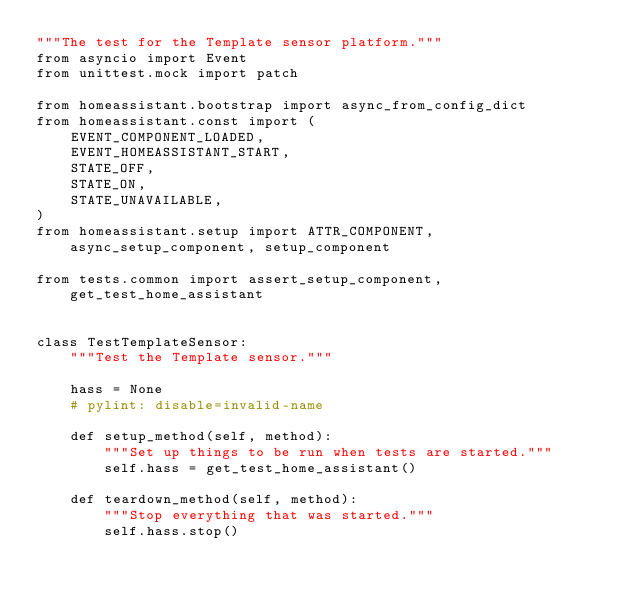Convert code to text. <code><loc_0><loc_0><loc_500><loc_500><_Python_>"""The test for the Template sensor platform."""
from asyncio import Event
from unittest.mock import patch

from homeassistant.bootstrap import async_from_config_dict
from homeassistant.const import (
    EVENT_COMPONENT_LOADED,
    EVENT_HOMEASSISTANT_START,
    STATE_OFF,
    STATE_ON,
    STATE_UNAVAILABLE,
)
from homeassistant.setup import ATTR_COMPONENT, async_setup_component, setup_component

from tests.common import assert_setup_component, get_test_home_assistant


class TestTemplateSensor:
    """Test the Template sensor."""

    hass = None
    # pylint: disable=invalid-name

    def setup_method(self, method):
        """Set up things to be run when tests are started."""
        self.hass = get_test_home_assistant()

    def teardown_method(self, method):
        """Stop everything that was started."""
        self.hass.stop()
</code> 